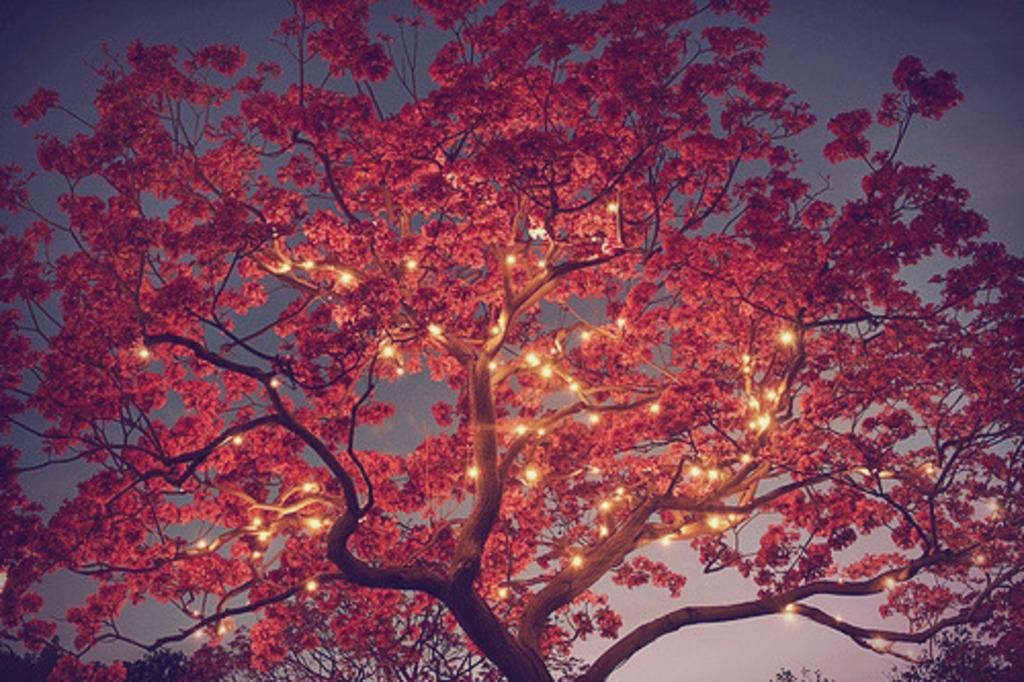What type of vegetation can be seen in the image? There are trees in the image. What else is visible in the image besides the trees? There are lights in the image. What part of the natural environment is visible in the image? The sky is visible in the image. Where are the trousers located in the image? There are no trousers present in the image. What type of furniture can be seen in the bedroom in the image? There is no bedroom present in the image. 